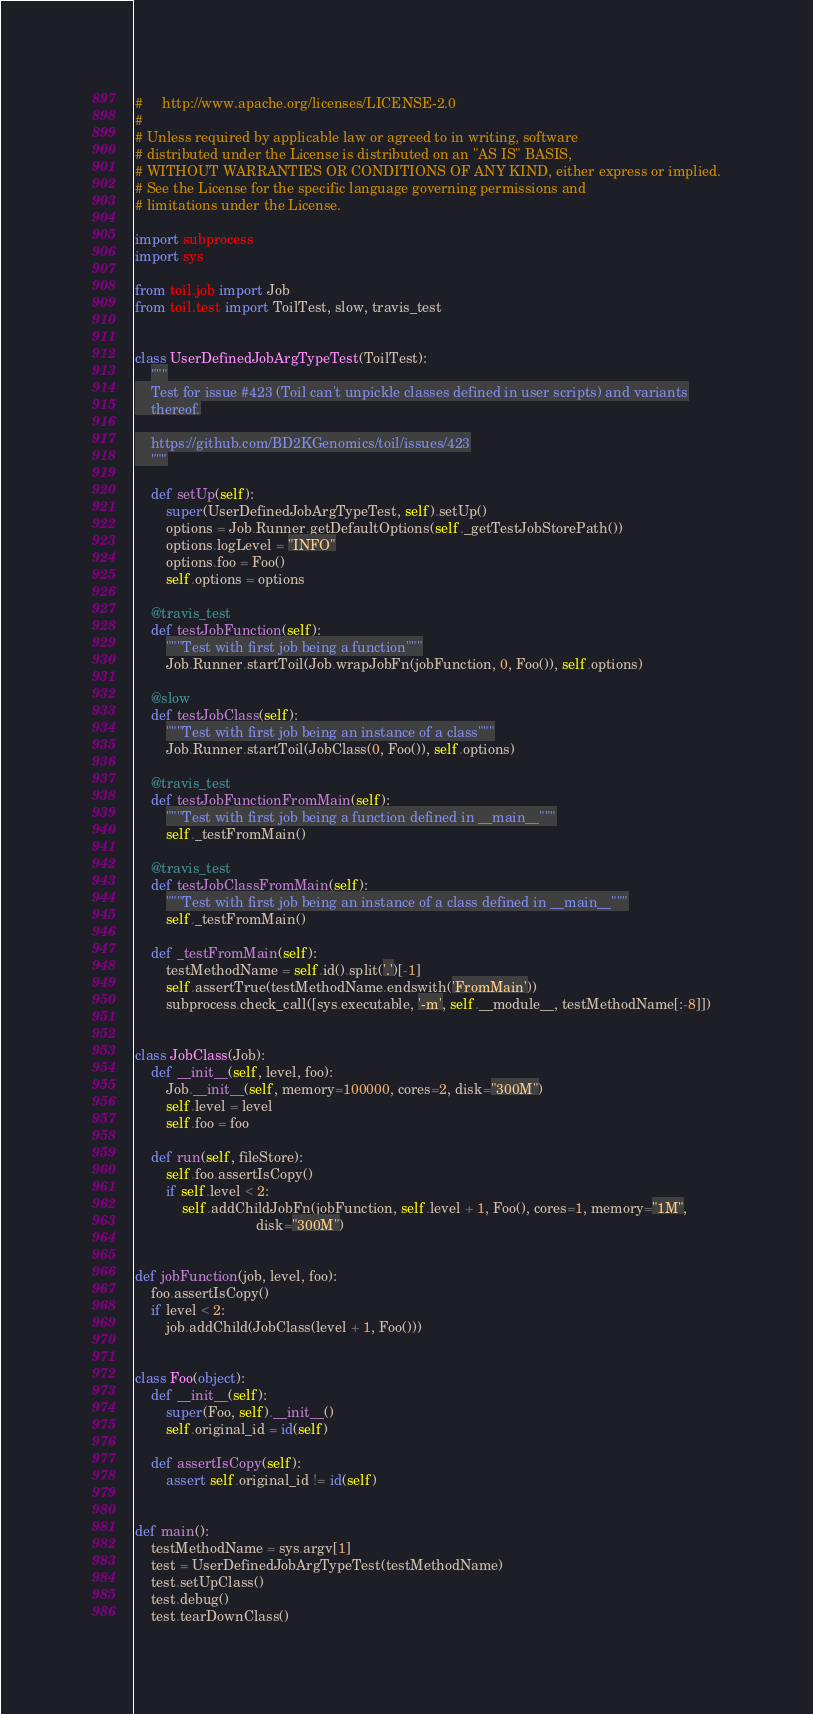<code> <loc_0><loc_0><loc_500><loc_500><_Python_>#     http://www.apache.org/licenses/LICENSE-2.0
#
# Unless required by applicable law or agreed to in writing, software
# distributed under the License is distributed on an "AS IS" BASIS,
# WITHOUT WARRANTIES OR CONDITIONS OF ANY KIND, either express or implied.
# See the License for the specific language governing permissions and
# limitations under the License.

import subprocess
import sys

from toil.job import Job
from toil.test import ToilTest, slow, travis_test


class UserDefinedJobArgTypeTest(ToilTest):
    """
    Test for issue #423 (Toil can't unpickle classes defined in user scripts) and variants
    thereof.

    https://github.com/BD2KGenomics/toil/issues/423
    """

    def setUp(self):
        super(UserDefinedJobArgTypeTest, self).setUp()
        options = Job.Runner.getDefaultOptions(self._getTestJobStorePath())
        options.logLevel = "INFO"
        options.foo = Foo()
        self.options = options
    
    @travis_test
    def testJobFunction(self):
        """Test with first job being a function"""
        Job.Runner.startToil(Job.wrapJobFn(jobFunction, 0, Foo()), self.options)

    @slow
    def testJobClass(self):
        """Test with first job being an instance of a class"""
        Job.Runner.startToil(JobClass(0, Foo()), self.options)
    
    @travis_test
    def testJobFunctionFromMain(self):
        """Test with first job being a function defined in __main__"""
        self._testFromMain()
    
    @travis_test
    def testJobClassFromMain(self):
        """Test with first job being an instance of a class defined in __main__"""
        self._testFromMain()

    def _testFromMain(self):
        testMethodName = self.id().split('.')[-1]
        self.assertTrue(testMethodName.endswith('FromMain'))
        subprocess.check_call([sys.executable, '-m', self.__module__, testMethodName[:-8]])


class JobClass(Job):
    def __init__(self, level, foo):
        Job.__init__(self, memory=100000, cores=2, disk="300M")
        self.level = level
        self.foo = foo

    def run(self, fileStore):
        self.foo.assertIsCopy()
        if self.level < 2:
            self.addChildJobFn(jobFunction, self.level + 1, Foo(), cores=1, memory="1M",
                               disk="300M")


def jobFunction(job, level, foo):
    foo.assertIsCopy()
    if level < 2:
        job.addChild(JobClass(level + 1, Foo()))


class Foo(object):
    def __init__(self):
        super(Foo, self).__init__()
        self.original_id = id(self)

    def assertIsCopy(self):
        assert self.original_id != id(self)


def main():
    testMethodName = sys.argv[1]
    test = UserDefinedJobArgTypeTest(testMethodName)
    test.setUpClass()
    test.debug()
    test.tearDownClass()
</code> 